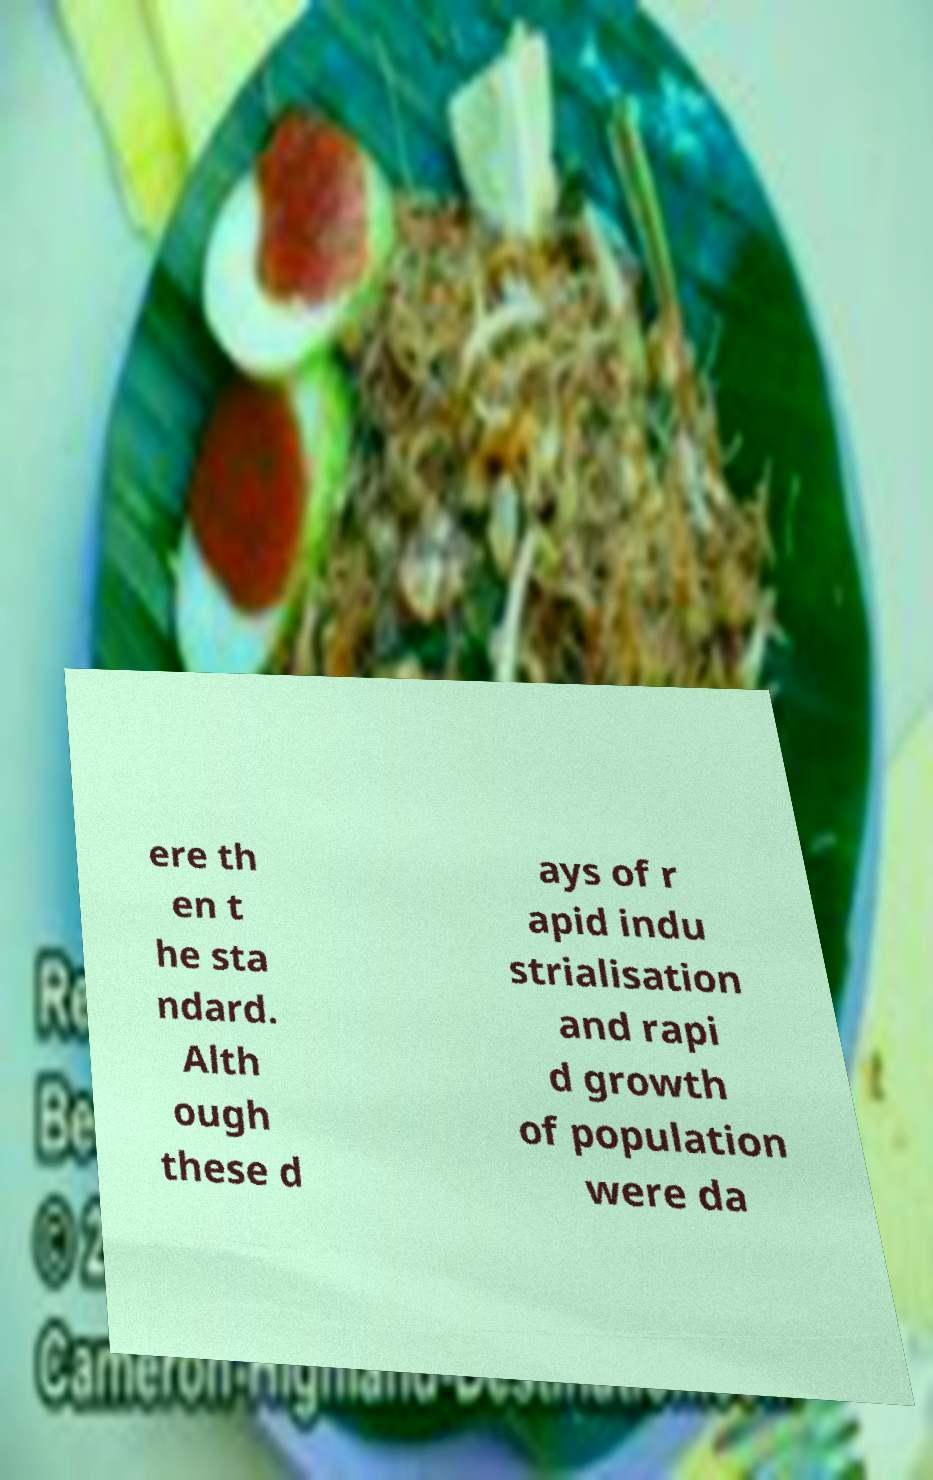Could you extract and type out the text from this image? ere th en t he sta ndard. Alth ough these d ays of r apid indu strialisation and rapi d growth of population were da 